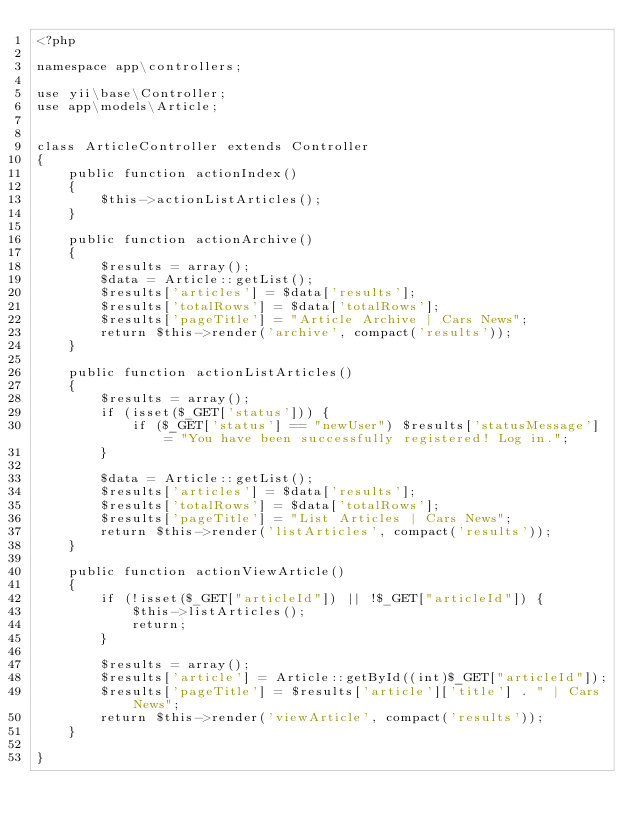Convert code to text. <code><loc_0><loc_0><loc_500><loc_500><_PHP_><?php

namespace app\controllers;

use yii\base\Controller;
use app\models\Article;


class ArticleController extends Controller
{
    public function actionIndex()
    {
        $this->actionListArticles();
    }

    public function actionArchive()
    {
        $results = array();
        $data = Article::getList();
        $results['articles'] = $data['results'];
        $results['totalRows'] = $data['totalRows'];
        $results['pageTitle'] = "Article Archive | Cars News";
        return $this->render('archive', compact('results'));
    }

    public function actionListArticles()
    {
        $results = array();
        if (isset($_GET['status'])) {
            if ($_GET['status'] == "newUser") $results['statusMessage'] = "You have been successfully registered! Log in.";
        }

        $data = Article::getList();
        $results['articles'] = $data['results'];
        $results['totalRows'] = $data['totalRows'];
        $results['pageTitle'] = "List Articles | Cars News";
        return $this->render('listArticles', compact('results'));
    }

    public function actionViewArticle()
    {
        if (!isset($_GET["articleId"]) || !$_GET["articleId"]) {
            $this->listArticles();
            return;
        }

        $results = array();
        $results['article'] = Article::getById((int)$_GET["articleId"]);
        $results['pageTitle'] = $results['article']['title'] . " | Cars News";
        return $this->render('viewArticle', compact('results'));
    }

}
</code> 